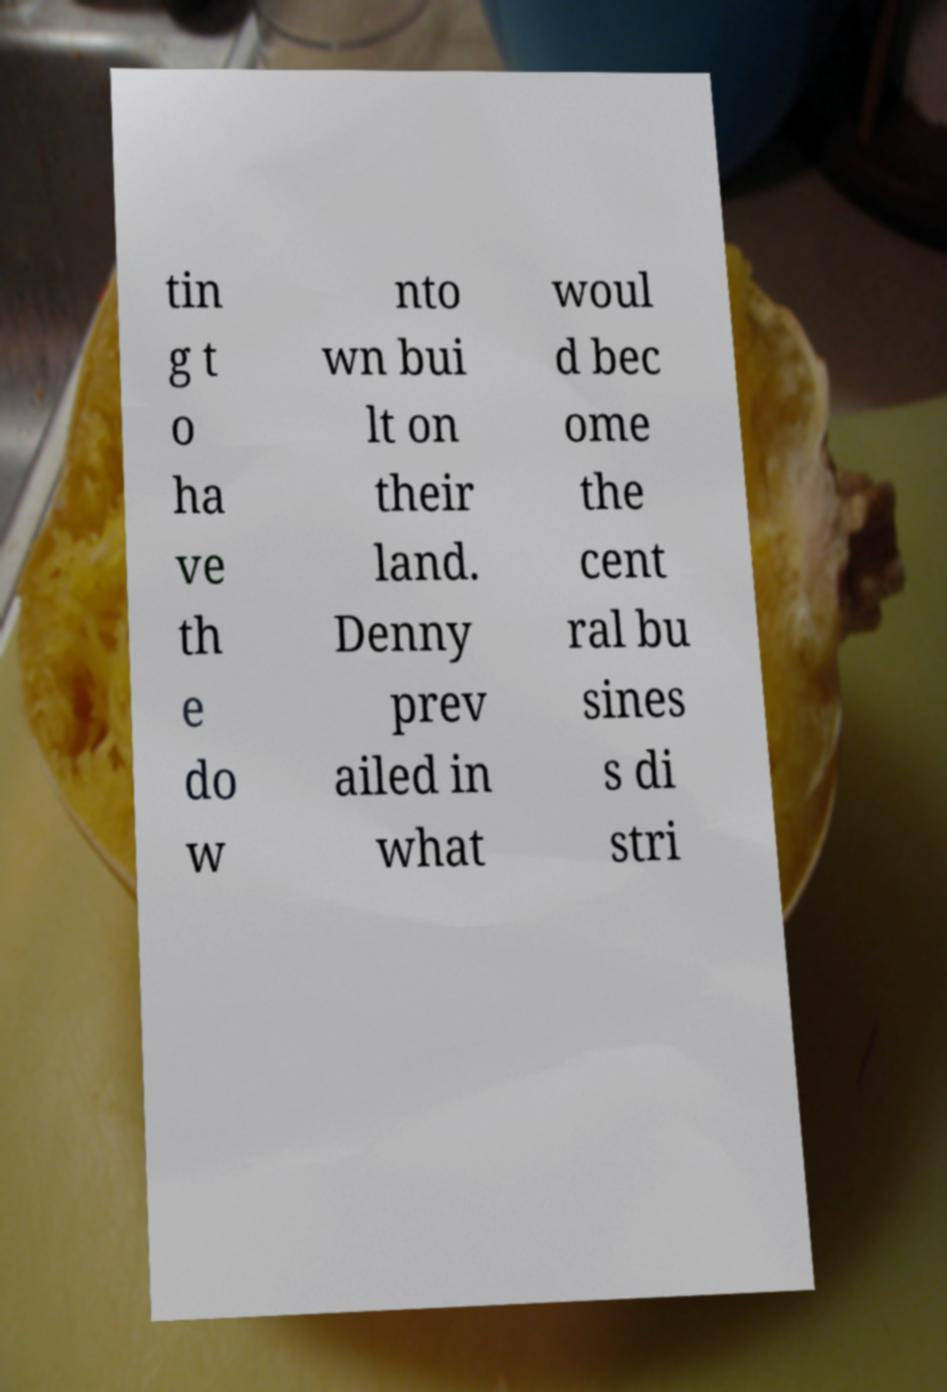Please read and relay the text visible in this image. What does it say? tin g t o ha ve th e do w nto wn bui lt on their land. Denny prev ailed in what woul d bec ome the cent ral bu sines s di stri 